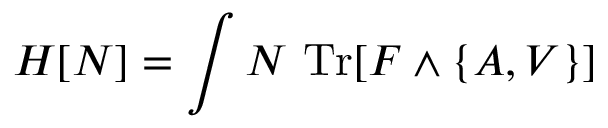Convert formula to latex. <formula><loc_0><loc_0><loc_500><loc_500>H [ N ] = \int N \ T r [ F \wedge \{ A , V \} ]</formula> 